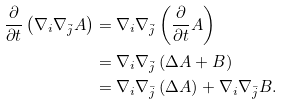Convert formula to latex. <formula><loc_0><loc_0><loc_500><loc_500>\frac { \partial } { \partial t } \left ( \nabla _ { i } \nabla _ { \bar { j } } A \right ) & = \nabla _ { i } \nabla _ { \bar { j } } \left ( \frac { \partial } { \partial t } A \right ) \\ & = \nabla _ { i } \nabla _ { \bar { j } } \left ( \Delta { A } + B \right ) \\ & = \nabla _ { i } \nabla _ { \bar { j } } \left ( \Delta { A } \right ) + \nabla _ { i } \nabla _ { \bar { j } } B .</formula> 